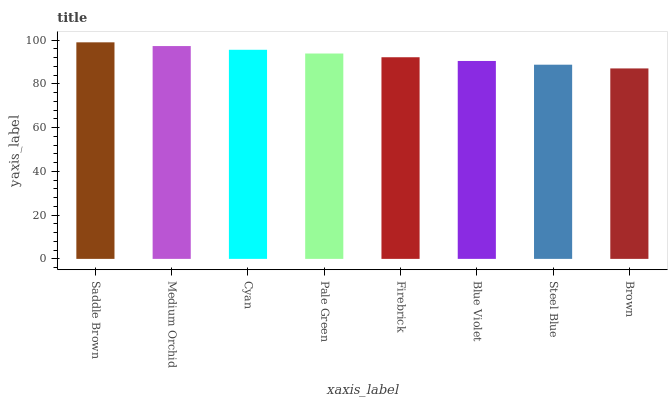Is Medium Orchid the minimum?
Answer yes or no. No. Is Medium Orchid the maximum?
Answer yes or no. No. Is Saddle Brown greater than Medium Orchid?
Answer yes or no. Yes. Is Medium Orchid less than Saddle Brown?
Answer yes or no. Yes. Is Medium Orchid greater than Saddle Brown?
Answer yes or no. No. Is Saddle Brown less than Medium Orchid?
Answer yes or no. No. Is Pale Green the high median?
Answer yes or no. Yes. Is Firebrick the low median?
Answer yes or no. Yes. Is Blue Violet the high median?
Answer yes or no. No. Is Medium Orchid the low median?
Answer yes or no. No. 